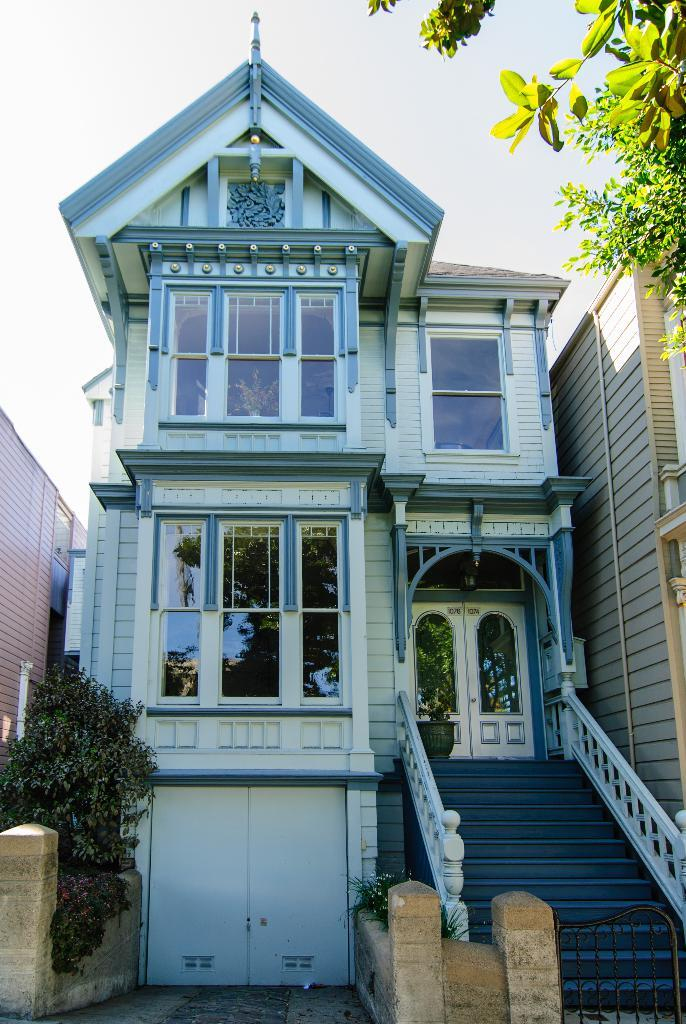What is located at the bottom of the image? There are plants, steps, and buildings at the bottom of the image. What type of vegetation can be seen at the bottom of the image? There are plants at the bottom of the image. What architectural feature is present at the bottom of the image? There are steps at the bottom of the image. What type of structure can be seen at the bottom of the image? There are buildings at the bottom of the image. What is visible in the top right corner of the image? There is a tree in the top right corner of the image. What is visible at the top of the image? There is sky visible at the top of the image. How many girls are serving the guests in the image? There are no girls or guests present in the image. What type of clothing is the servant wearing in the image? There is no servant present in the image. 